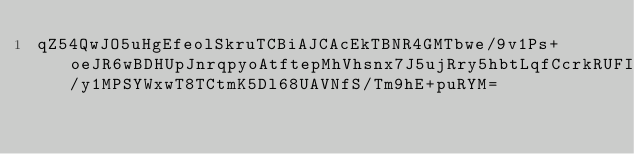<code> <loc_0><loc_0><loc_500><loc_500><_SML_>qZ54QwJO5uHgEfeolSkruTCBiAJCAcEkTBNR4GMTbwe/9v1Ps+oeJR6wBDHUpJnrqpyoAtftepMhVhsnx7J5ujRry5hbtLqfCcrkRUFIj0VX7OX6FbL9AkIBEadAGYZvee86jzJAq7KmqWacugJOWknu3Wyj6qCTvMF1qKU/y1MPSYWxwT8TCtmK5Dl68UAVNfS/Tm9hE+puRYM=</code> 